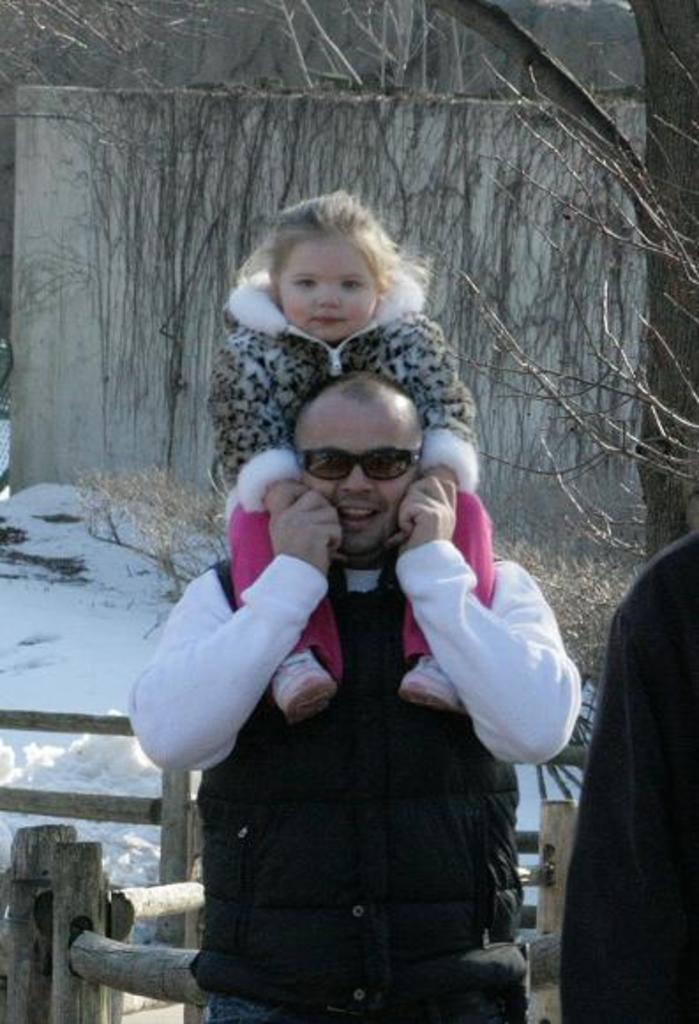Describe this image in one or two sentences. As we can see in the image in the front there are three persons and wooden sticks. There is snow, wall and dry tree. The persons in the front are wearing black color dresses. 